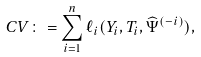Convert formula to latex. <formula><loc_0><loc_0><loc_500><loc_500>C V \colon = \sum _ { i = 1 } ^ { n } \ell _ { i } ( Y _ { i } , T _ { i } , \widehat { \Psi } ^ { ( - i ) } ) ,</formula> 